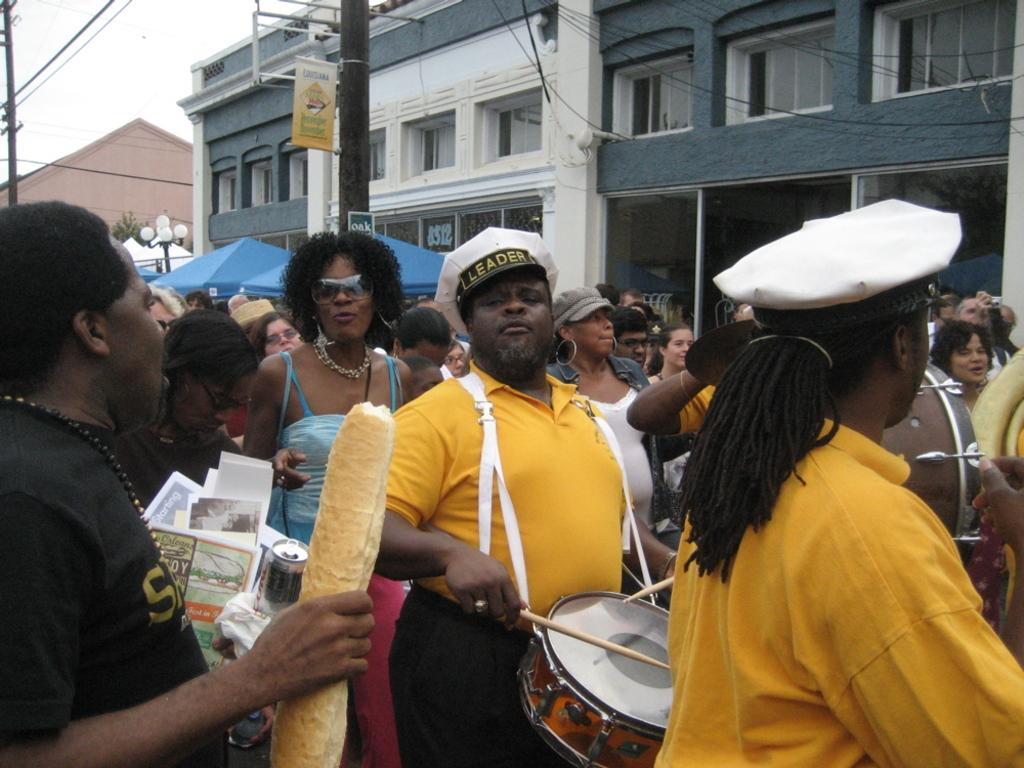How many people are in the image? There is a group of people in the image. What is one person in the group wearing? One person is wearing a drum set. What type of headwear is the person with the drum set wearing? The person with the drum set is wearing a cap. What can be seen in the background of the image? There are buildings with windows in the background of the image. What is the condition of the sky in the image? The sky is clear in the image. How many planes can be seen flying in the image? There are no planes visible in the image. What type of zephyr is present in the image? There is no zephyr present in the image. 